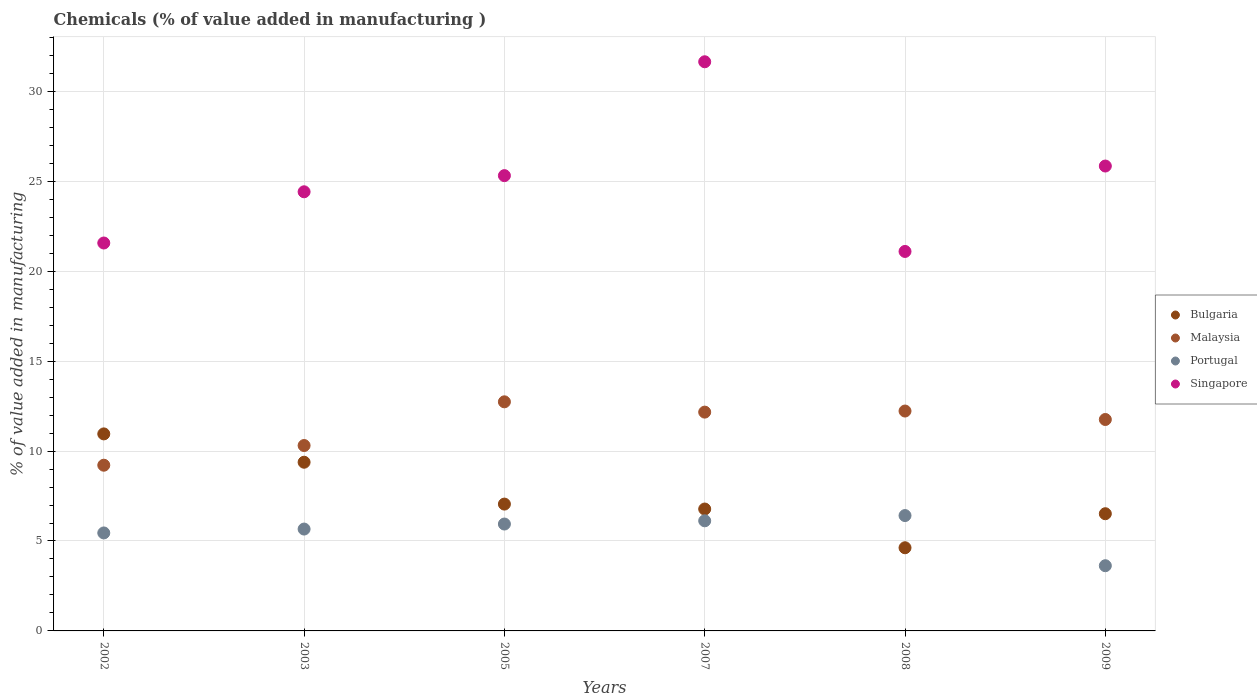What is the value added in manufacturing chemicals in Bulgaria in 2005?
Your answer should be compact. 7.05. Across all years, what is the maximum value added in manufacturing chemicals in Malaysia?
Your answer should be very brief. 12.74. Across all years, what is the minimum value added in manufacturing chemicals in Bulgaria?
Ensure brevity in your answer.  4.62. In which year was the value added in manufacturing chemicals in Malaysia minimum?
Provide a short and direct response. 2002. What is the total value added in manufacturing chemicals in Bulgaria in the graph?
Provide a succinct answer. 45.31. What is the difference between the value added in manufacturing chemicals in Bulgaria in 2007 and that in 2008?
Ensure brevity in your answer.  2.15. What is the difference between the value added in manufacturing chemicals in Singapore in 2003 and the value added in manufacturing chemicals in Bulgaria in 2009?
Your response must be concise. 17.9. What is the average value added in manufacturing chemicals in Bulgaria per year?
Ensure brevity in your answer.  7.55. In the year 2009, what is the difference between the value added in manufacturing chemicals in Singapore and value added in manufacturing chemicals in Malaysia?
Your answer should be compact. 14.09. In how many years, is the value added in manufacturing chemicals in Malaysia greater than 26 %?
Offer a very short reply. 0. What is the ratio of the value added in manufacturing chemicals in Malaysia in 2007 to that in 2009?
Offer a terse response. 1.03. What is the difference between the highest and the second highest value added in manufacturing chemicals in Singapore?
Offer a very short reply. 5.8. What is the difference between the highest and the lowest value added in manufacturing chemicals in Bulgaria?
Offer a terse response. 6.33. Is the sum of the value added in manufacturing chemicals in Portugal in 2008 and 2009 greater than the maximum value added in manufacturing chemicals in Malaysia across all years?
Keep it short and to the point. No. Is it the case that in every year, the sum of the value added in manufacturing chemicals in Malaysia and value added in manufacturing chemicals in Bulgaria  is greater than the sum of value added in manufacturing chemicals in Singapore and value added in manufacturing chemicals in Portugal?
Ensure brevity in your answer.  No. How many dotlines are there?
Keep it short and to the point. 4. What is the difference between two consecutive major ticks on the Y-axis?
Your answer should be compact. 5. Are the values on the major ticks of Y-axis written in scientific E-notation?
Offer a very short reply. No. Where does the legend appear in the graph?
Ensure brevity in your answer.  Center right. What is the title of the graph?
Offer a terse response. Chemicals (% of value added in manufacturing ). What is the label or title of the Y-axis?
Offer a very short reply. % of value added in manufacturing. What is the % of value added in manufacturing in Bulgaria in 2002?
Make the answer very short. 10.95. What is the % of value added in manufacturing of Malaysia in 2002?
Your answer should be compact. 9.21. What is the % of value added in manufacturing of Portugal in 2002?
Your answer should be compact. 5.45. What is the % of value added in manufacturing of Singapore in 2002?
Ensure brevity in your answer.  21.57. What is the % of value added in manufacturing of Bulgaria in 2003?
Provide a short and direct response. 9.38. What is the % of value added in manufacturing in Malaysia in 2003?
Your response must be concise. 10.31. What is the % of value added in manufacturing of Portugal in 2003?
Make the answer very short. 5.66. What is the % of value added in manufacturing in Singapore in 2003?
Ensure brevity in your answer.  24.42. What is the % of value added in manufacturing in Bulgaria in 2005?
Ensure brevity in your answer.  7.05. What is the % of value added in manufacturing in Malaysia in 2005?
Your answer should be compact. 12.74. What is the % of value added in manufacturing of Portugal in 2005?
Keep it short and to the point. 5.94. What is the % of value added in manufacturing in Singapore in 2005?
Offer a very short reply. 25.32. What is the % of value added in manufacturing in Bulgaria in 2007?
Offer a terse response. 6.78. What is the % of value added in manufacturing of Malaysia in 2007?
Keep it short and to the point. 12.17. What is the % of value added in manufacturing of Portugal in 2007?
Make the answer very short. 6.12. What is the % of value added in manufacturing of Singapore in 2007?
Your response must be concise. 31.65. What is the % of value added in manufacturing of Bulgaria in 2008?
Provide a succinct answer. 4.62. What is the % of value added in manufacturing of Malaysia in 2008?
Make the answer very short. 12.23. What is the % of value added in manufacturing of Portugal in 2008?
Provide a short and direct response. 6.41. What is the % of value added in manufacturing in Singapore in 2008?
Keep it short and to the point. 21.1. What is the % of value added in manufacturing in Bulgaria in 2009?
Provide a short and direct response. 6.52. What is the % of value added in manufacturing in Malaysia in 2009?
Make the answer very short. 11.76. What is the % of value added in manufacturing in Portugal in 2009?
Make the answer very short. 3.63. What is the % of value added in manufacturing of Singapore in 2009?
Offer a terse response. 25.85. Across all years, what is the maximum % of value added in manufacturing of Bulgaria?
Keep it short and to the point. 10.95. Across all years, what is the maximum % of value added in manufacturing of Malaysia?
Your answer should be compact. 12.74. Across all years, what is the maximum % of value added in manufacturing in Portugal?
Provide a succinct answer. 6.41. Across all years, what is the maximum % of value added in manufacturing of Singapore?
Provide a short and direct response. 31.65. Across all years, what is the minimum % of value added in manufacturing in Bulgaria?
Offer a terse response. 4.62. Across all years, what is the minimum % of value added in manufacturing in Malaysia?
Your answer should be very brief. 9.21. Across all years, what is the minimum % of value added in manufacturing of Portugal?
Provide a short and direct response. 3.63. Across all years, what is the minimum % of value added in manufacturing of Singapore?
Provide a succinct answer. 21.1. What is the total % of value added in manufacturing in Bulgaria in the graph?
Your answer should be very brief. 45.31. What is the total % of value added in manufacturing of Malaysia in the graph?
Provide a succinct answer. 68.41. What is the total % of value added in manufacturing of Portugal in the graph?
Provide a short and direct response. 33.22. What is the total % of value added in manufacturing in Singapore in the graph?
Keep it short and to the point. 149.9. What is the difference between the % of value added in manufacturing in Bulgaria in 2002 and that in 2003?
Your answer should be compact. 1.58. What is the difference between the % of value added in manufacturing of Malaysia in 2002 and that in 2003?
Offer a terse response. -1.09. What is the difference between the % of value added in manufacturing in Portugal in 2002 and that in 2003?
Your response must be concise. -0.22. What is the difference between the % of value added in manufacturing of Singapore in 2002 and that in 2003?
Offer a very short reply. -2.85. What is the difference between the % of value added in manufacturing in Bulgaria in 2002 and that in 2005?
Your answer should be compact. 3.9. What is the difference between the % of value added in manufacturing of Malaysia in 2002 and that in 2005?
Give a very brief answer. -3.52. What is the difference between the % of value added in manufacturing in Portugal in 2002 and that in 2005?
Provide a succinct answer. -0.49. What is the difference between the % of value added in manufacturing of Singapore in 2002 and that in 2005?
Your answer should be compact. -3.75. What is the difference between the % of value added in manufacturing in Bulgaria in 2002 and that in 2007?
Your answer should be very brief. 4.18. What is the difference between the % of value added in manufacturing in Malaysia in 2002 and that in 2007?
Your answer should be compact. -2.95. What is the difference between the % of value added in manufacturing of Portugal in 2002 and that in 2007?
Make the answer very short. -0.67. What is the difference between the % of value added in manufacturing in Singapore in 2002 and that in 2007?
Your answer should be very brief. -10.08. What is the difference between the % of value added in manufacturing of Bulgaria in 2002 and that in 2008?
Make the answer very short. 6.33. What is the difference between the % of value added in manufacturing of Malaysia in 2002 and that in 2008?
Your response must be concise. -3.01. What is the difference between the % of value added in manufacturing in Portugal in 2002 and that in 2008?
Give a very brief answer. -0.97. What is the difference between the % of value added in manufacturing in Singapore in 2002 and that in 2008?
Make the answer very short. 0.47. What is the difference between the % of value added in manufacturing in Bulgaria in 2002 and that in 2009?
Make the answer very short. 4.44. What is the difference between the % of value added in manufacturing of Malaysia in 2002 and that in 2009?
Offer a very short reply. -2.54. What is the difference between the % of value added in manufacturing in Portugal in 2002 and that in 2009?
Your answer should be compact. 1.82. What is the difference between the % of value added in manufacturing in Singapore in 2002 and that in 2009?
Your response must be concise. -4.28. What is the difference between the % of value added in manufacturing of Bulgaria in 2003 and that in 2005?
Offer a very short reply. 2.33. What is the difference between the % of value added in manufacturing in Malaysia in 2003 and that in 2005?
Provide a short and direct response. -2.43. What is the difference between the % of value added in manufacturing in Portugal in 2003 and that in 2005?
Make the answer very short. -0.28. What is the difference between the % of value added in manufacturing in Singapore in 2003 and that in 2005?
Provide a succinct answer. -0.9. What is the difference between the % of value added in manufacturing of Bulgaria in 2003 and that in 2007?
Make the answer very short. 2.6. What is the difference between the % of value added in manufacturing of Malaysia in 2003 and that in 2007?
Your response must be concise. -1.86. What is the difference between the % of value added in manufacturing in Portugal in 2003 and that in 2007?
Your answer should be very brief. -0.46. What is the difference between the % of value added in manufacturing in Singapore in 2003 and that in 2007?
Keep it short and to the point. -7.23. What is the difference between the % of value added in manufacturing of Bulgaria in 2003 and that in 2008?
Your answer should be very brief. 4.76. What is the difference between the % of value added in manufacturing in Malaysia in 2003 and that in 2008?
Your response must be concise. -1.92. What is the difference between the % of value added in manufacturing of Portugal in 2003 and that in 2008?
Your answer should be very brief. -0.75. What is the difference between the % of value added in manufacturing in Singapore in 2003 and that in 2008?
Give a very brief answer. 3.32. What is the difference between the % of value added in manufacturing in Bulgaria in 2003 and that in 2009?
Your response must be concise. 2.86. What is the difference between the % of value added in manufacturing of Malaysia in 2003 and that in 2009?
Offer a very short reply. -1.45. What is the difference between the % of value added in manufacturing in Portugal in 2003 and that in 2009?
Provide a short and direct response. 2.04. What is the difference between the % of value added in manufacturing of Singapore in 2003 and that in 2009?
Your response must be concise. -1.43. What is the difference between the % of value added in manufacturing in Bulgaria in 2005 and that in 2007?
Make the answer very short. 0.27. What is the difference between the % of value added in manufacturing in Malaysia in 2005 and that in 2007?
Your answer should be very brief. 0.57. What is the difference between the % of value added in manufacturing in Portugal in 2005 and that in 2007?
Offer a very short reply. -0.18. What is the difference between the % of value added in manufacturing of Singapore in 2005 and that in 2007?
Give a very brief answer. -6.33. What is the difference between the % of value added in manufacturing of Bulgaria in 2005 and that in 2008?
Provide a short and direct response. 2.43. What is the difference between the % of value added in manufacturing of Malaysia in 2005 and that in 2008?
Provide a short and direct response. 0.51. What is the difference between the % of value added in manufacturing in Portugal in 2005 and that in 2008?
Your response must be concise. -0.47. What is the difference between the % of value added in manufacturing of Singapore in 2005 and that in 2008?
Make the answer very short. 4.22. What is the difference between the % of value added in manufacturing in Bulgaria in 2005 and that in 2009?
Ensure brevity in your answer.  0.54. What is the difference between the % of value added in manufacturing of Malaysia in 2005 and that in 2009?
Offer a terse response. 0.98. What is the difference between the % of value added in manufacturing in Portugal in 2005 and that in 2009?
Your answer should be compact. 2.32. What is the difference between the % of value added in manufacturing in Singapore in 2005 and that in 2009?
Your answer should be very brief. -0.53. What is the difference between the % of value added in manufacturing of Bulgaria in 2007 and that in 2008?
Keep it short and to the point. 2.15. What is the difference between the % of value added in manufacturing of Malaysia in 2007 and that in 2008?
Provide a succinct answer. -0.06. What is the difference between the % of value added in manufacturing of Portugal in 2007 and that in 2008?
Ensure brevity in your answer.  -0.29. What is the difference between the % of value added in manufacturing in Singapore in 2007 and that in 2008?
Make the answer very short. 10.55. What is the difference between the % of value added in manufacturing in Bulgaria in 2007 and that in 2009?
Ensure brevity in your answer.  0.26. What is the difference between the % of value added in manufacturing in Malaysia in 2007 and that in 2009?
Your answer should be compact. 0.41. What is the difference between the % of value added in manufacturing of Portugal in 2007 and that in 2009?
Make the answer very short. 2.5. What is the difference between the % of value added in manufacturing of Singapore in 2007 and that in 2009?
Your response must be concise. 5.8. What is the difference between the % of value added in manufacturing of Bulgaria in 2008 and that in 2009?
Give a very brief answer. -1.89. What is the difference between the % of value added in manufacturing in Malaysia in 2008 and that in 2009?
Your answer should be very brief. 0.47. What is the difference between the % of value added in manufacturing in Portugal in 2008 and that in 2009?
Give a very brief answer. 2.79. What is the difference between the % of value added in manufacturing in Singapore in 2008 and that in 2009?
Provide a short and direct response. -4.75. What is the difference between the % of value added in manufacturing of Bulgaria in 2002 and the % of value added in manufacturing of Malaysia in 2003?
Offer a very short reply. 0.65. What is the difference between the % of value added in manufacturing in Bulgaria in 2002 and the % of value added in manufacturing in Portugal in 2003?
Provide a succinct answer. 5.29. What is the difference between the % of value added in manufacturing of Bulgaria in 2002 and the % of value added in manufacturing of Singapore in 2003?
Give a very brief answer. -13.46. What is the difference between the % of value added in manufacturing in Malaysia in 2002 and the % of value added in manufacturing in Portugal in 2003?
Your answer should be very brief. 3.55. What is the difference between the % of value added in manufacturing in Malaysia in 2002 and the % of value added in manufacturing in Singapore in 2003?
Give a very brief answer. -15.2. What is the difference between the % of value added in manufacturing of Portugal in 2002 and the % of value added in manufacturing of Singapore in 2003?
Keep it short and to the point. -18.97. What is the difference between the % of value added in manufacturing of Bulgaria in 2002 and the % of value added in manufacturing of Malaysia in 2005?
Your response must be concise. -1.78. What is the difference between the % of value added in manufacturing in Bulgaria in 2002 and the % of value added in manufacturing in Portugal in 2005?
Your answer should be compact. 5.01. What is the difference between the % of value added in manufacturing of Bulgaria in 2002 and the % of value added in manufacturing of Singapore in 2005?
Your answer should be very brief. -14.36. What is the difference between the % of value added in manufacturing of Malaysia in 2002 and the % of value added in manufacturing of Portugal in 2005?
Keep it short and to the point. 3.27. What is the difference between the % of value added in manufacturing of Malaysia in 2002 and the % of value added in manufacturing of Singapore in 2005?
Your response must be concise. -16.1. What is the difference between the % of value added in manufacturing in Portugal in 2002 and the % of value added in manufacturing in Singapore in 2005?
Your answer should be compact. -19.87. What is the difference between the % of value added in manufacturing in Bulgaria in 2002 and the % of value added in manufacturing in Malaysia in 2007?
Your response must be concise. -1.21. What is the difference between the % of value added in manufacturing of Bulgaria in 2002 and the % of value added in manufacturing of Portugal in 2007?
Your answer should be very brief. 4.83. What is the difference between the % of value added in manufacturing of Bulgaria in 2002 and the % of value added in manufacturing of Singapore in 2007?
Ensure brevity in your answer.  -20.69. What is the difference between the % of value added in manufacturing in Malaysia in 2002 and the % of value added in manufacturing in Portugal in 2007?
Your response must be concise. 3.09. What is the difference between the % of value added in manufacturing of Malaysia in 2002 and the % of value added in manufacturing of Singapore in 2007?
Provide a short and direct response. -22.43. What is the difference between the % of value added in manufacturing of Portugal in 2002 and the % of value added in manufacturing of Singapore in 2007?
Keep it short and to the point. -26.2. What is the difference between the % of value added in manufacturing of Bulgaria in 2002 and the % of value added in manufacturing of Malaysia in 2008?
Your answer should be compact. -1.27. What is the difference between the % of value added in manufacturing of Bulgaria in 2002 and the % of value added in manufacturing of Portugal in 2008?
Your answer should be compact. 4.54. What is the difference between the % of value added in manufacturing of Bulgaria in 2002 and the % of value added in manufacturing of Singapore in 2008?
Provide a short and direct response. -10.14. What is the difference between the % of value added in manufacturing of Malaysia in 2002 and the % of value added in manufacturing of Portugal in 2008?
Offer a terse response. 2.8. What is the difference between the % of value added in manufacturing of Malaysia in 2002 and the % of value added in manufacturing of Singapore in 2008?
Provide a succinct answer. -11.89. What is the difference between the % of value added in manufacturing in Portugal in 2002 and the % of value added in manufacturing in Singapore in 2008?
Your answer should be very brief. -15.65. What is the difference between the % of value added in manufacturing in Bulgaria in 2002 and the % of value added in manufacturing in Malaysia in 2009?
Your answer should be compact. -0.8. What is the difference between the % of value added in manufacturing in Bulgaria in 2002 and the % of value added in manufacturing in Portugal in 2009?
Your answer should be very brief. 7.33. What is the difference between the % of value added in manufacturing of Bulgaria in 2002 and the % of value added in manufacturing of Singapore in 2009?
Offer a very short reply. -14.89. What is the difference between the % of value added in manufacturing of Malaysia in 2002 and the % of value added in manufacturing of Portugal in 2009?
Make the answer very short. 5.59. What is the difference between the % of value added in manufacturing of Malaysia in 2002 and the % of value added in manufacturing of Singapore in 2009?
Your answer should be very brief. -16.63. What is the difference between the % of value added in manufacturing in Portugal in 2002 and the % of value added in manufacturing in Singapore in 2009?
Provide a short and direct response. -20.4. What is the difference between the % of value added in manufacturing in Bulgaria in 2003 and the % of value added in manufacturing in Malaysia in 2005?
Make the answer very short. -3.36. What is the difference between the % of value added in manufacturing of Bulgaria in 2003 and the % of value added in manufacturing of Portugal in 2005?
Your answer should be compact. 3.44. What is the difference between the % of value added in manufacturing in Bulgaria in 2003 and the % of value added in manufacturing in Singapore in 2005?
Give a very brief answer. -15.94. What is the difference between the % of value added in manufacturing of Malaysia in 2003 and the % of value added in manufacturing of Portugal in 2005?
Your answer should be very brief. 4.37. What is the difference between the % of value added in manufacturing of Malaysia in 2003 and the % of value added in manufacturing of Singapore in 2005?
Your answer should be compact. -15.01. What is the difference between the % of value added in manufacturing of Portugal in 2003 and the % of value added in manufacturing of Singapore in 2005?
Your answer should be compact. -19.65. What is the difference between the % of value added in manufacturing of Bulgaria in 2003 and the % of value added in manufacturing of Malaysia in 2007?
Give a very brief answer. -2.79. What is the difference between the % of value added in manufacturing in Bulgaria in 2003 and the % of value added in manufacturing in Portugal in 2007?
Offer a very short reply. 3.26. What is the difference between the % of value added in manufacturing in Bulgaria in 2003 and the % of value added in manufacturing in Singapore in 2007?
Your response must be concise. -22.27. What is the difference between the % of value added in manufacturing of Malaysia in 2003 and the % of value added in manufacturing of Portugal in 2007?
Ensure brevity in your answer.  4.19. What is the difference between the % of value added in manufacturing in Malaysia in 2003 and the % of value added in manufacturing in Singapore in 2007?
Make the answer very short. -21.34. What is the difference between the % of value added in manufacturing of Portugal in 2003 and the % of value added in manufacturing of Singapore in 2007?
Offer a very short reply. -25.98. What is the difference between the % of value added in manufacturing in Bulgaria in 2003 and the % of value added in manufacturing in Malaysia in 2008?
Ensure brevity in your answer.  -2.85. What is the difference between the % of value added in manufacturing of Bulgaria in 2003 and the % of value added in manufacturing of Portugal in 2008?
Ensure brevity in your answer.  2.97. What is the difference between the % of value added in manufacturing in Bulgaria in 2003 and the % of value added in manufacturing in Singapore in 2008?
Ensure brevity in your answer.  -11.72. What is the difference between the % of value added in manufacturing in Malaysia in 2003 and the % of value added in manufacturing in Portugal in 2008?
Provide a succinct answer. 3.89. What is the difference between the % of value added in manufacturing of Malaysia in 2003 and the % of value added in manufacturing of Singapore in 2008?
Offer a terse response. -10.79. What is the difference between the % of value added in manufacturing of Portugal in 2003 and the % of value added in manufacturing of Singapore in 2008?
Provide a short and direct response. -15.44. What is the difference between the % of value added in manufacturing of Bulgaria in 2003 and the % of value added in manufacturing of Malaysia in 2009?
Provide a succinct answer. -2.38. What is the difference between the % of value added in manufacturing in Bulgaria in 2003 and the % of value added in manufacturing in Portugal in 2009?
Offer a very short reply. 5.75. What is the difference between the % of value added in manufacturing in Bulgaria in 2003 and the % of value added in manufacturing in Singapore in 2009?
Keep it short and to the point. -16.47. What is the difference between the % of value added in manufacturing of Malaysia in 2003 and the % of value added in manufacturing of Portugal in 2009?
Your answer should be very brief. 6.68. What is the difference between the % of value added in manufacturing of Malaysia in 2003 and the % of value added in manufacturing of Singapore in 2009?
Your answer should be very brief. -15.54. What is the difference between the % of value added in manufacturing in Portugal in 2003 and the % of value added in manufacturing in Singapore in 2009?
Your response must be concise. -20.19. What is the difference between the % of value added in manufacturing in Bulgaria in 2005 and the % of value added in manufacturing in Malaysia in 2007?
Your answer should be compact. -5.11. What is the difference between the % of value added in manufacturing of Bulgaria in 2005 and the % of value added in manufacturing of Portugal in 2007?
Keep it short and to the point. 0.93. What is the difference between the % of value added in manufacturing of Bulgaria in 2005 and the % of value added in manufacturing of Singapore in 2007?
Provide a succinct answer. -24.59. What is the difference between the % of value added in manufacturing in Malaysia in 2005 and the % of value added in manufacturing in Portugal in 2007?
Offer a terse response. 6.62. What is the difference between the % of value added in manufacturing in Malaysia in 2005 and the % of value added in manufacturing in Singapore in 2007?
Give a very brief answer. -18.91. What is the difference between the % of value added in manufacturing of Portugal in 2005 and the % of value added in manufacturing of Singapore in 2007?
Your answer should be very brief. -25.7. What is the difference between the % of value added in manufacturing in Bulgaria in 2005 and the % of value added in manufacturing in Malaysia in 2008?
Your response must be concise. -5.17. What is the difference between the % of value added in manufacturing of Bulgaria in 2005 and the % of value added in manufacturing of Portugal in 2008?
Ensure brevity in your answer.  0.64. What is the difference between the % of value added in manufacturing of Bulgaria in 2005 and the % of value added in manufacturing of Singapore in 2008?
Offer a terse response. -14.05. What is the difference between the % of value added in manufacturing in Malaysia in 2005 and the % of value added in manufacturing in Portugal in 2008?
Your answer should be compact. 6.32. What is the difference between the % of value added in manufacturing in Malaysia in 2005 and the % of value added in manufacturing in Singapore in 2008?
Provide a short and direct response. -8.36. What is the difference between the % of value added in manufacturing of Portugal in 2005 and the % of value added in manufacturing of Singapore in 2008?
Offer a terse response. -15.16. What is the difference between the % of value added in manufacturing in Bulgaria in 2005 and the % of value added in manufacturing in Malaysia in 2009?
Make the answer very short. -4.7. What is the difference between the % of value added in manufacturing in Bulgaria in 2005 and the % of value added in manufacturing in Portugal in 2009?
Your response must be concise. 3.43. What is the difference between the % of value added in manufacturing in Bulgaria in 2005 and the % of value added in manufacturing in Singapore in 2009?
Provide a succinct answer. -18.8. What is the difference between the % of value added in manufacturing of Malaysia in 2005 and the % of value added in manufacturing of Portugal in 2009?
Ensure brevity in your answer.  9.11. What is the difference between the % of value added in manufacturing of Malaysia in 2005 and the % of value added in manufacturing of Singapore in 2009?
Keep it short and to the point. -13.11. What is the difference between the % of value added in manufacturing of Portugal in 2005 and the % of value added in manufacturing of Singapore in 2009?
Ensure brevity in your answer.  -19.91. What is the difference between the % of value added in manufacturing in Bulgaria in 2007 and the % of value added in manufacturing in Malaysia in 2008?
Keep it short and to the point. -5.45. What is the difference between the % of value added in manufacturing in Bulgaria in 2007 and the % of value added in manufacturing in Portugal in 2008?
Provide a short and direct response. 0.36. What is the difference between the % of value added in manufacturing in Bulgaria in 2007 and the % of value added in manufacturing in Singapore in 2008?
Provide a short and direct response. -14.32. What is the difference between the % of value added in manufacturing in Malaysia in 2007 and the % of value added in manufacturing in Portugal in 2008?
Offer a very short reply. 5.75. What is the difference between the % of value added in manufacturing in Malaysia in 2007 and the % of value added in manufacturing in Singapore in 2008?
Give a very brief answer. -8.93. What is the difference between the % of value added in manufacturing in Portugal in 2007 and the % of value added in manufacturing in Singapore in 2008?
Offer a very short reply. -14.98. What is the difference between the % of value added in manufacturing of Bulgaria in 2007 and the % of value added in manufacturing of Malaysia in 2009?
Ensure brevity in your answer.  -4.98. What is the difference between the % of value added in manufacturing in Bulgaria in 2007 and the % of value added in manufacturing in Portugal in 2009?
Offer a terse response. 3.15. What is the difference between the % of value added in manufacturing in Bulgaria in 2007 and the % of value added in manufacturing in Singapore in 2009?
Your response must be concise. -19.07. What is the difference between the % of value added in manufacturing in Malaysia in 2007 and the % of value added in manufacturing in Portugal in 2009?
Your response must be concise. 8.54. What is the difference between the % of value added in manufacturing of Malaysia in 2007 and the % of value added in manufacturing of Singapore in 2009?
Your answer should be very brief. -13.68. What is the difference between the % of value added in manufacturing in Portugal in 2007 and the % of value added in manufacturing in Singapore in 2009?
Your response must be concise. -19.73. What is the difference between the % of value added in manufacturing of Bulgaria in 2008 and the % of value added in manufacturing of Malaysia in 2009?
Give a very brief answer. -7.13. What is the difference between the % of value added in manufacturing of Bulgaria in 2008 and the % of value added in manufacturing of Portugal in 2009?
Offer a terse response. 1. What is the difference between the % of value added in manufacturing of Bulgaria in 2008 and the % of value added in manufacturing of Singapore in 2009?
Give a very brief answer. -21.22. What is the difference between the % of value added in manufacturing in Malaysia in 2008 and the % of value added in manufacturing in Portugal in 2009?
Your response must be concise. 8.6. What is the difference between the % of value added in manufacturing in Malaysia in 2008 and the % of value added in manufacturing in Singapore in 2009?
Ensure brevity in your answer.  -13.62. What is the difference between the % of value added in manufacturing of Portugal in 2008 and the % of value added in manufacturing of Singapore in 2009?
Offer a very short reply. -19.43. What is the average % of value added in manufacturing in Bulgaria per year?
Provide a succinct answer. 7.55. What is the average % of value added in manufacturing of Malaysia per year?
Your response must be concise. 11.4. What is the average % of value added in manufacturing in Portugal per year?
Your answer should be very brief. 5.54. What is the average % of value added in manufacturing of Singapore per year?
Your response must be concise. 24.98. In the year 2002, what is the difference between the % of value added in manufacturing in Bulgaria and % of value added in manufacturing in Malaysia?
Offer a terse response. 1.74. In the year 2002, what is the difference between the % of value added in manufacturing of Bulgaria and % of value added in manufacturing of Portugal?
Keep it short and to the point. 5.51. In the year 2002, what is the difference between the % of value added in manufacturing of Bulgaria and % of value added in manufacturing of Singapore?
Give a very brief answer. -10.61. In the year 2002, what is the difference between the % of value added in manufacturing of Malaysia and % of value added in manufacturing of Portugal?
Offer a terse response. 3.77. In the year 2002, what is the difference between the % of value added in manufacturing of Malaysia and % of value added in manufacturing of Singapore?
Your answer should be very brief. -12.36. In the year 2002, what is the difference between the % of value added in manufacturing in Portugal and % of value added in manufacturing in Singapore?
Your answer should be compact. -16.12. In the year 2003, what is the difference between the % of value added in manufacturing of Bulgaria and % of value added in manufacturing of Malaysia?
Provide a short and direct response. -0.93. In the year 2003, what is the difference between the % of value added in manufacturing of Bulgaria and % of value added in manufacturing of Portugal?
Make the answer very short. 3.72. In the year 2003, what is the difference between the % of value added in manufacturing in Bulgaria and % of value added in manufacturing in Singapore?
Your answer should be compact. -15.04. In the year 2003, what is the difference between the % of value added in manufacturing in Malaysia and % of value added in manufacturing in Portugal?
Make the answer very short. 4.64. In the year 2003, what is the difference between the % of value added in manufacturing of Malaysia and % of value added in manufacturing of Singapore?
Offer a very short reply. -14.11. In the year 2003, what is the difference between the % of value added in manufacturing in Portugal and % of value added in manufacturing in Singapore?
Offer a terse response. -18.75. In the year 2005, what is the difference between the % of value added in manufacturing of Bulgaria and % of value added in manufacturing of Malaysia?
Offer a terse response. -5.69. In the year 2005, what is the difference between the % of value added in manufacturing of Bulgaria and % of value added in manufacturing of Portugal?
Ensure brevity in your answer.  1.11. In the year 2005, what is the difference between the % of value added in manufacturing in Bulgaria and % of value added in manufacturing in Singapore?
Ensure brevity in your answer.  -18.26. In the year 2005, what is the difference between the % of value added in manufacturing of Malaysia and % of value added in manufacturing of Portugal?
Your response must be concise. 6.8. In the year 2005, what is the difference between the % of value added in manufacturing of Malaysia and % of value added in manufacturing of Singapore?
Offer a terse response. -12.58. In the year 2005, what is the difference between the % of value added in manufacturing of Portugal and % of value added in manufacturing of Singapore?
Your answer should be very brief. -19.37. In the year 2007, what is the difference between the % of value added in manufacturing in Bulgaria and % of value added in manufacturing in Malaysia?
Provide a short and direct response. -5.39. In the year 2007, what is the difference between the % of value added in manufacturing in Bulgaria and % of value added in manufacturing in Portugal?
Give a very brief answer. 0.66. In the year 2007, what is the difference between the % of value added in manufacturing of Bulgaria and % of value added in manufacturing of Singapore?
Make the answer very short. -24.87. In the year 2007, what is the difference between the % of value added in manufacturing of Malaysia and % of value added in manufacturing of Portugal?
Provide a short and direct response. 6.04. In the year 2007, what is the difference between the % of value added in manufacturing of Malaysia and % of value added in manufacturing of Singapore?
Your response must be concise. -19.48. In the year 2007, what is the difference between the % of value added in manufacturing of Portugal and % of value added in manufacturing of Singapore?
Your response must be concise. -25.52. In the year 2008, what is the difference between the % of value added in manufacturing in Bulgaria and % of value added in manufacturing in Malaysia?
Your response must be concise. -7.6. In the year 2008, what is the difference between the % of value added in manufacturing in Bulgaria and % of value added in manufacturing in Portugal?
Give a very brief answer. -1.79. In the year 2008, what is the difference between the % of value added in manufacturing of Bulgaria and % of value added in manufacturing of Singapore?
Ensure brevity in your answer.  -16.48. In the year 2008, what is the difference between the % of value added in manufacturing in Malaysia and % of value added in manufacturing in Portugal?
Your answer should be very brief. 5.81. In the year 2008, what is the difference between the % of value added in manufacturing of Malaysia and % of value added in manufacturing of Singapore?
Your answer should be very brief. -8.87. In the year 2008, what is the difference between the % of value added in manufacturing of Portugal and % of value added in manufacturing of Singapore?
Your answer should be compact. -14.69. In the year 2009, what is the difference between the % of value added in manufacturing of Bulgaria and % of value added in manufacturing of Malaysia?
Provide a short and direct response. -5.24. In the year 2009, what is the difference between the % of value added in manufacturing in Bulgaria and % of value added in manufacturing in Portugal?
Your answer should be compact. 2.89. In the year 2009, what is the difference between the % of value added in manufacturing of Bulgaria and % of value added in manufacturing of Singapore?
Provide a short and direct response. -19.33. In the year 2009, what is the difference between the % of value added in manufacturing of Malaysia and % of value added in manufacturing of Portugal?
Your answer should be very brief. 8.13. In the year 2009, what is the difference between the % of value added in manufacturing in Malaysia and % of value added in manufacturing in Singapore?
Make the answer very short. -14.09. In the year 2009, what is the difference between the % of value added in manufacturing of Portugal and % of value added in manufacturing of Singapore?
Ensure brevity in your answer.  -22.22. What is the ratio of the % of value added in manufacturing in Bulgaria in 2002 to that in 2003?
Provide a succinct answer. 1.17. What is the ratio of the % of value added in manufacturing in Malaysia in 2002 to that in 2003?
Provide a succinct answer. 0.89. What is the ratio of the % of value added in manufacturing of Portugal in 2002 to that in 2003?
Provide a short and direct response. 0.96. What is the ratio of the % of value added in manufacturing in Singapore in 2002 to that in 2003?
Offer a terse response. 0.88. What is the ratio of the % of value added in manufacturing of Bulgaria in 2002 to that in 2005?
Offer a terse response. 1.55. What is the ratio of the % of value added in manufacturing in Malaysia in 2002 to that in 2005?
Provide a succinct answer. 0.72. What is the ratio of the % of value added in manufacturing of Portugal in 2002 to that in 2005?
Ensure brevity in your answer.  0.92. What is the ratio of the % of value added in manufacturing in Singapore in 2002 to that in 2005?
Offer a very short reply. 0.85. What is the ratio of the % of value added in manufacturing of Bulgaria in 2002 to that in 2007?
Your response must be concise. 1.62. What is the ratio of the % of value added in manufacturing in Malaysia in 2002 to that in 2007?
Your answer should be compact. 0.76. What is the ratio of the % of value added in manufacturing of Portugal in 2002 to that in 2007?
Provide a succinct answer. 0.89. What is the ratio of the % of value added in manufacturing in Singapore in 2002 to that in 2007?
Offer a terse response. 0.68. What is the ratio of the % of value added in manufacturing of Bulgaria in 2002 to that in 2008?
Provide a short and direct response. 2.37. What is the ratio of the % of value added in manufacturing in Malaysia in 2002 to that in 2008?
Make the answer very short. 0.75. What is the ratio of the % of value added in manufacturing in Portugal in 2002 to that in 2008?
Offer a very short reply. 0.85. What is the ratio of the % of value added in manufacturing in Singapore in 2002 to that in 2008?
Give a very brief answer. 1.02. What is the ratio of the % of value added in manufacturing of Bulgaria in 2002 to that in 2009?
Your response must be concise. 1.68. What is the ratio of the % of value added in manufacturing in Malaysia in 2002 to that in 2009?
Give a very brief answer. 0.78. What is the ratio of the % of value added in manufacturing of Portugal in 2002 to that in 2009?
Your answer should be very brief. 1.5. What is the ratio of the % of value added in manufacturing of Singapore in 2002 to that in 2009?
Offer a terse response. 0.83. What is the ratio of the % of value added in manufacturing of Bulgaria in 2003 to that in 2005?
Provide a succinct answer. 1.33. What is the ratio of the % of value added in manufacturing in Malaysia in 2003 to that in 2005?
Your answer should be very brief. 0.81. What is the ratio of the % of value added in manufacturing of Portugal in 2003 to that in 2005?
Give a very brief answer. 0.95. What is the ratio of the % of value added in manufacturing of Singapore in 2003 to that in 2005?
Offer a very short reply. 0.96. What is the ratio of the % of value added in manufacturing in Bulgaria in 2003 to that in 2007?
Your answer should be very brief. 1.38. What is the ratio of the % of value added in manufacturing of Malaysia in 2003 to that in 2007?
Provide a short and direct response. 0.85. What is the ratio of the % of value added in manufacturing in Portugal in 2003 to that in 2007?
Give a very brief answer. 0.93. What is the ratio of the % of value added in manufacturing of Singapore in 2003 to that in 2007?
Keep it short and to the point. 0.77. What is the ratio of the % of value added in manufacturing of Bulgaria in 2003 to that in 2008?
Your response must be concise. 2.03. What is the ratio of the % of value added in manufacturing in Malaysia in 2003 to that in 2008?
Your answer should be very brief. 0.84. What is the ratio of the % of value added in manufacturing in Portugal in 2003 to that in 2008?
Give a very brief answer. 0.88. What is the ratio of the % of value added in manufacturing in Singapore in 2003 to that in 2008?
Offer a very short reply. 1.16. What is the ratio of the % of value added in manufacturing of Bulgaria in 2003 to that in 2009?
Provide a succinct answer. 1.44. What is the ratio of the % of value added in manufacturing in Malaysia in 2003 to that in 2009?
Make the answer very short. 0.88. What is the ratio of the % of value added in manufacturing in Portugal in 2003 to that in 2009?
Your answer should be very brief. 1.56. What is the ratio of the % of value added in manufacturing of Singapore in 2003 to that in 2009?
Offer a terse response. 0.94. What is the ratio of the % of value added in manufacturing in Bulgaria in 2005 to that in 2007?
Keep it short and to the point. 1.04. What is the ratio of the % of value added in manufacturing in Malaysia in 2005 to that in 2007?
Ensure brevity in your answer.  1.05. What is the ratio of the % of value added in manufacturing in Portugal in 2005 to that in 2007?
Give a very brief answer. 0.97. What is the ratio of the % of value added in manufacturing of Singapore in 2005 to that in 2007?
Make the answer very short. 0.8. What is the ratio of the % of value added in manufacturing of Bulgaria in 2005 to that in 2008?
Keep it short and to the point. 1.52. What is the ratio of the % of value added in manufacturing in Malaysia in 2005 to that in 2008?
Offer a very short reply. 1.04. What is the ratio of the % of value added in manufacturing in Portugal in 2005 to that in 2008?
Make the answer very short. 0.93. What is the ratio of the % of value added in manufacturing in Singapore in 2005 to that in 2008?
Ensure brevity in your answer.  1.2. What is the ratio of the % of value added in manufacturing of Bulgaria in 2005 to that in 2009?
Keep it short and to the point. 1.08. What is the ratio of the % of value added in manufacturing of Malaysia in 2005 to that in 2009?
Keep it short and to the point. 1.08. What is the ratio of the % of value added in manufacturing of Portugal in 2005 to that in 2009?
Ensure brevity in your answer.  1.64. What is the ratio of the % of value added in manufacturing in Singapore in 2005 to that in 2009?
Offer a terse response. 0.98. What is the ratio of the % of value added in manufacturing in Bulgaria in 2007 to that in 2008?
Give a very brief answer. 1.47. What is the ratio of the % of value added in manufacturing in Malaysia in 2007 to that in 2008?
Give a very brief answer. 1. What is the ratio of the % of value added in manufacturing of Portugal in 2007 to that in 2008?
Your response must be concise. 0.95. What is the ratio of the % of value added in manufacturing in Singapore in 2007 to that in 2008?
Your answer should be very brief. 1.5. What is the ratio of the % of value added in manufacturing of Bulgaria in 2007 to that in 2009?
Make the answer very short. 1.04. What is the ratio of the % of value added in manufacturing in Malaysia in 2007 to that in 2009?
Give a very brief answer. 1.03. What is the ratio of the % of value added in manufacturing in Portugal in 2007 to that in 2009?
Your answer should be compact. 1.69. What is the ratio of the % of value added in manufacturing in Singapore in 2007 to that in 2009?
Make the answer very short. 1.22. What is the ratio of the % of value added in manufacturing of Bulgaria in 2008 to that in 2009?
Offer a terse response. 0.71. What is the ratio of the % of value added in manufacturing of Portugal in 2008 to that in 2009?
Offer a terse response. 1.77. What is the ratio of the % of value added in manufacturing in Singapore in 2008 to that in 2009?
Ensure brevity in your answer.  0.82. What is the difference between the highest and the second highest % of value added in manufacturing in Bulgaria?
Make the answer very short. 1.58. What is the difference between the highest and the second highest % of value added in manufacturing of Malaysia?
Ensure brevity in your answer.  0.51. What is the difference between the highest and the second highest % of value added in manufacturing in Portugal?
Keep it short and to the point. 0.29. What is the difference between the highest and the second highest % of value added in manufacturing of Singapore?
Keep it short and to the point. 5.8. What is the difference between the highest and the lowest % of value added in manufacturing of Bulgaria?
Your answer should be compact. 6.33. What is the difference between the highest and the lowest % of value added in manufacturing of Malaysia?
Give a very brief answer. 3.52. What is the difference between the highest and the lowest % of value added in manufacturing in Portugal?
Offer a terse response. 2.79. What is the difference between the highest and the lowest % of value added in manufacturing of Singapore?
Make the answer very short. 10.55. 